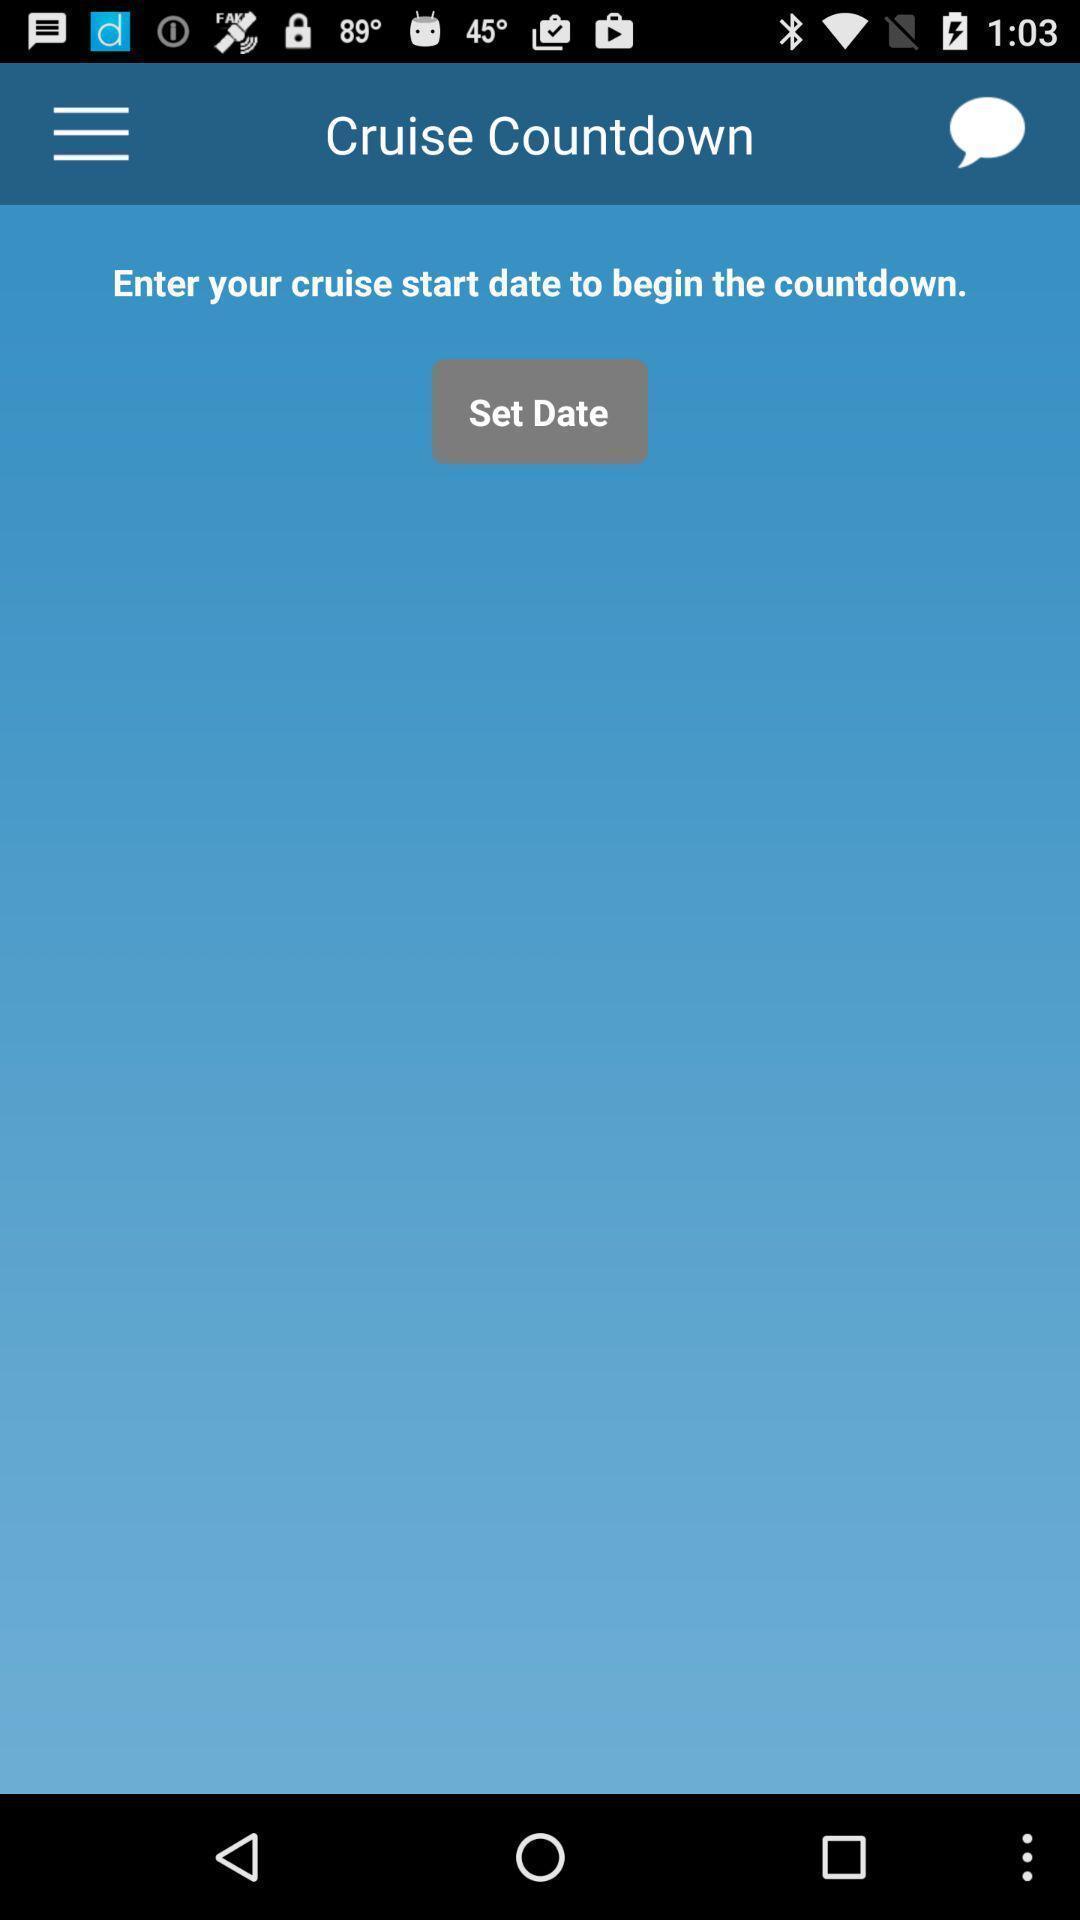Summarize the information in this screenshot. Screen shows cruise countdown of a travel app. 